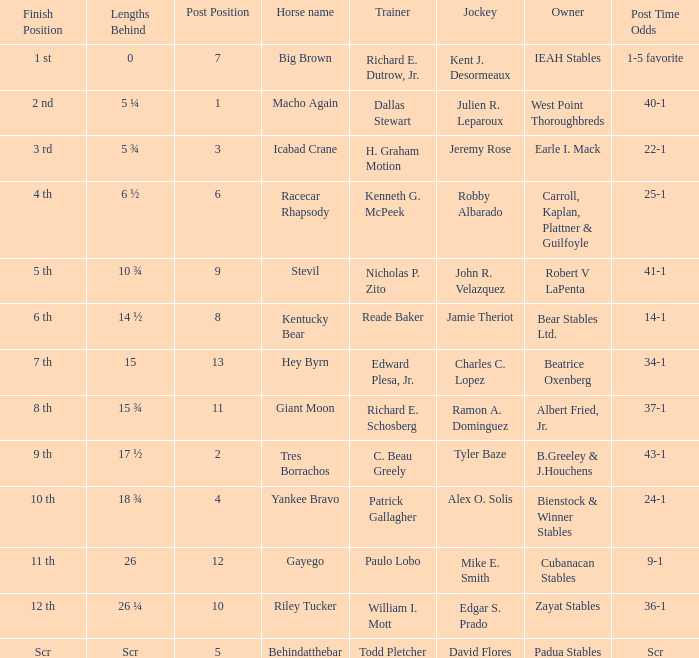What's the lengths behind of Jockey Ramon A. Dominguez? 15 ¾. 